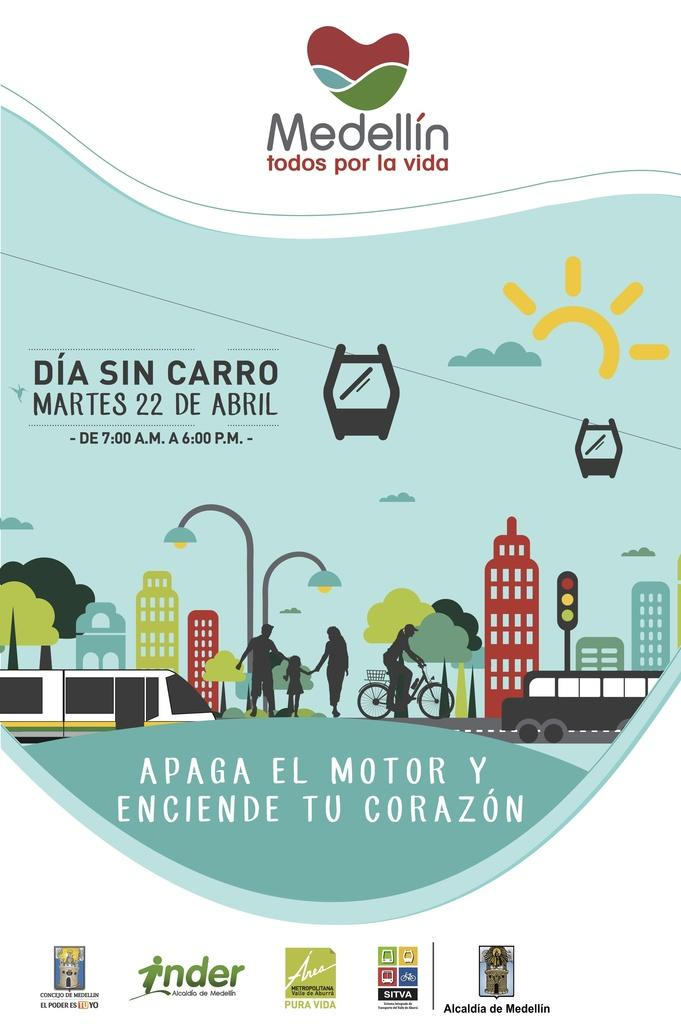<image>
Create a compact narrative representing the image presented. April 22 is the date of DIA SIN CARRO as advertised by Medellin whose motto is "todos por la vida". 